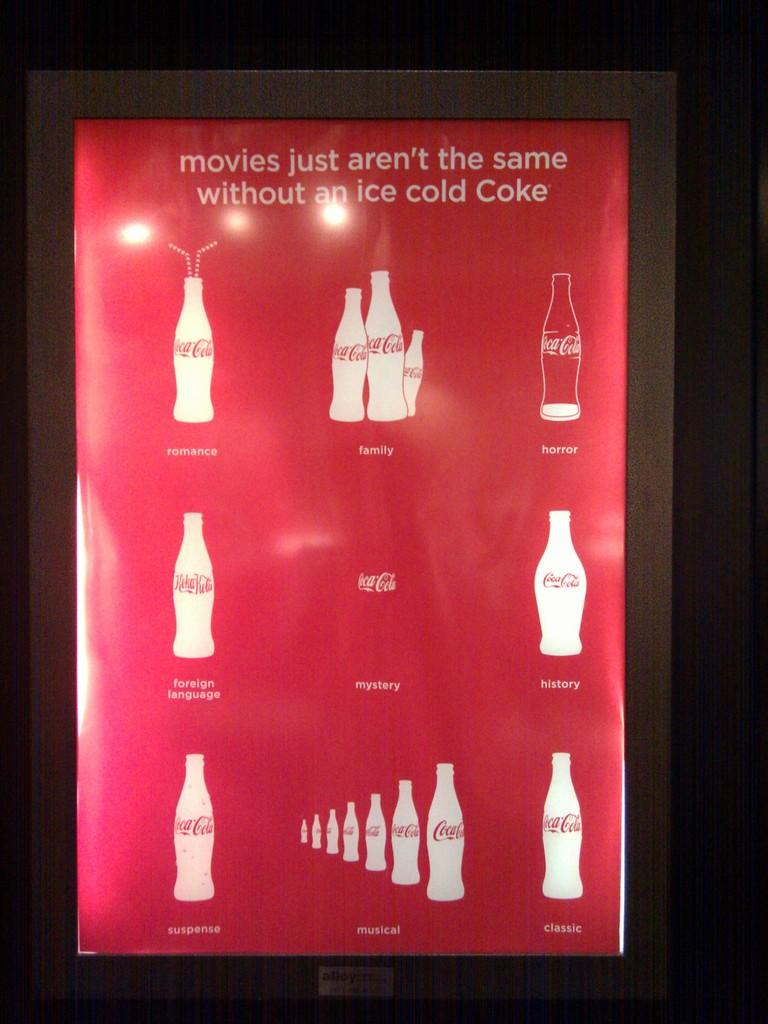<image>
Write a terse but informative summary of the picture. a poster for coca-cola that states that movies are not the same without an ice cold one 